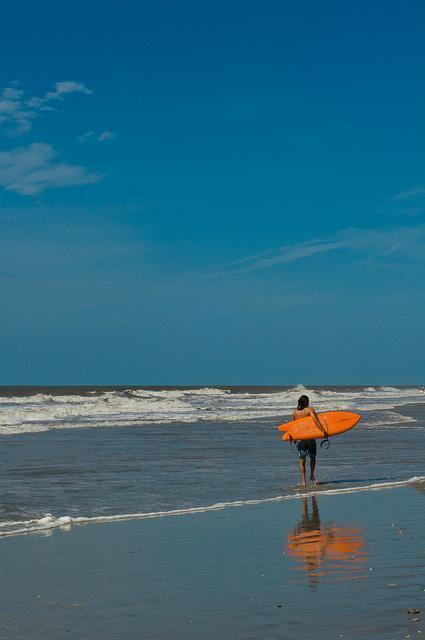How many bears are wearing hats?
Give a very brief answer. 0. 